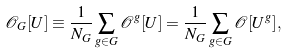Convert formula to latex. <formula><loc_0><loc_0><loc_500><loc_500>\mathcal { O } _ { G } [ U ] \equiv \frac { 1 } { N _ { G } } \sum _ { g \in G } \mathcal { O } ^ { g } [ U ] = \frac { 1 } { N _ { G } } \sum _ { g \in G } \mathcal { O } [ U ^ { g } ] ,</formula> 